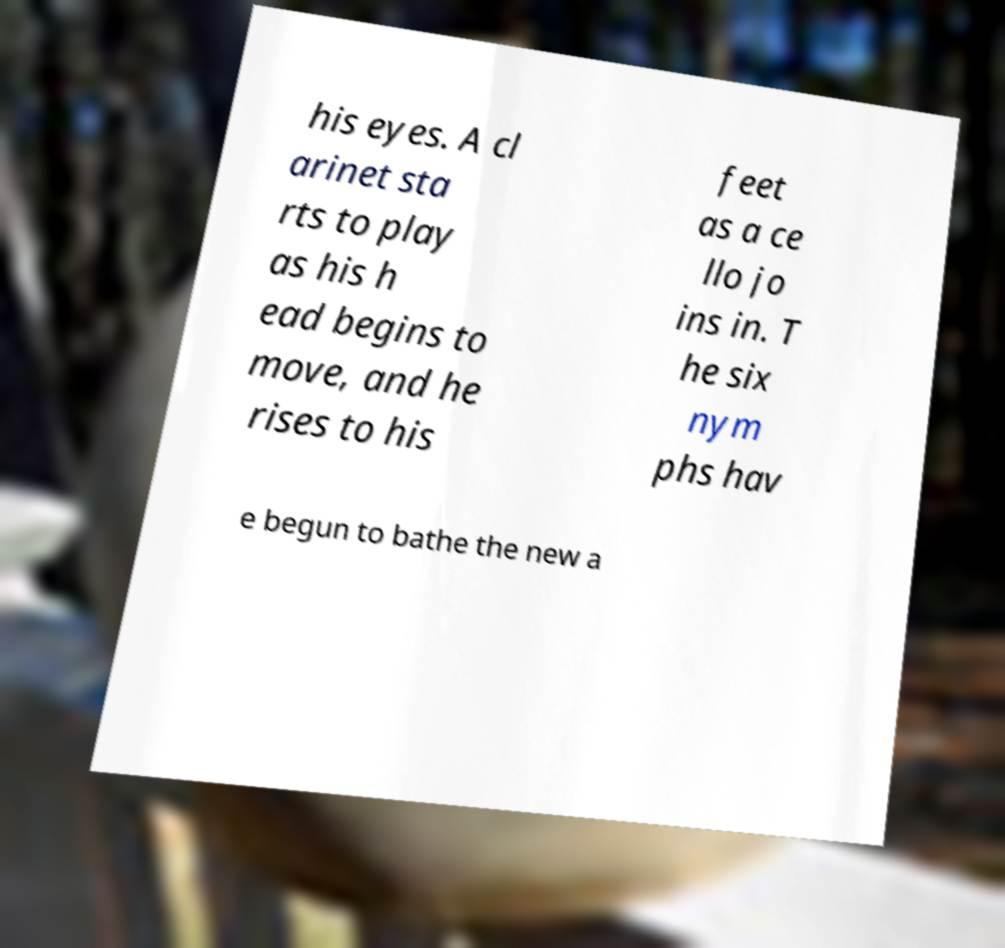Could you assist in decoding the text presented in this image and type it out clearly? his eyes. A cl arinet sta rts to play as his h ead begins to move, and he rises to his feet as a ce llo jo ins in. T he six nym phs hav e begun to bathe the new a 